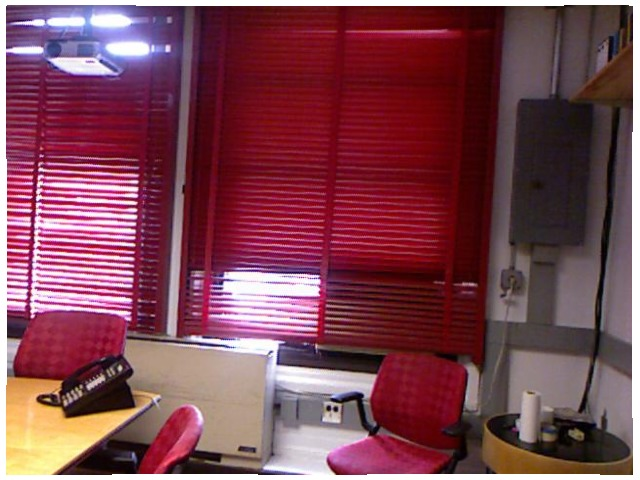<image>
Is the blinds behind the chair? Yes. From this viewpoint, the blinds is positioned behind the chair, with the chair partially or fully occluding the blinds. Is there a window behind the chair? No. The window is not behind the chair. From this viewpoint, the window appears to be positioned elsewhere in the scene. 